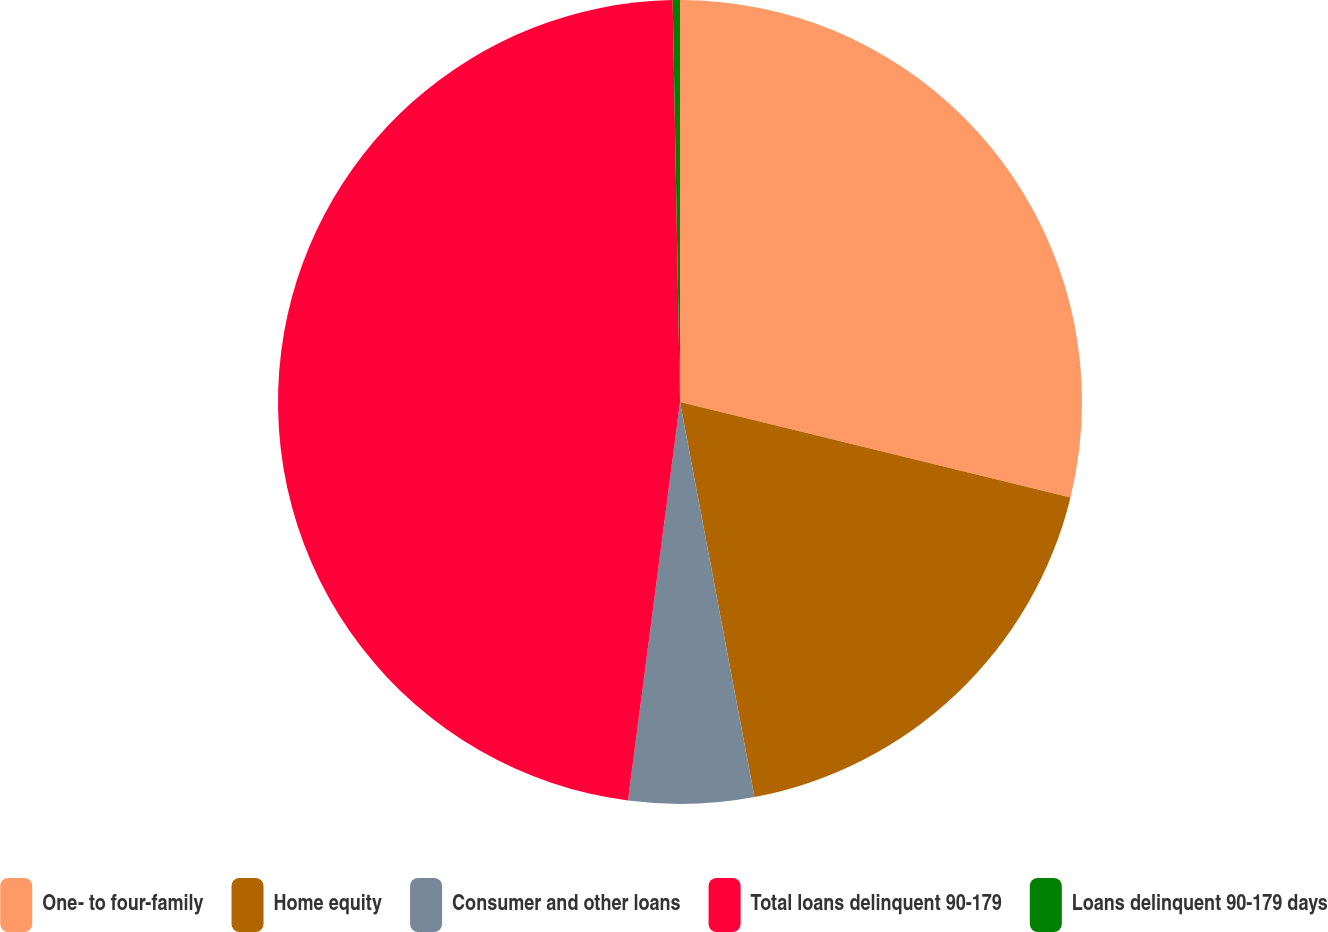<chart> <loc_0><loc_0><loc_500><loc_500><pie_chart><fcel>One- to four-family<fcel>Home equity<fcel>Consumer and other loans<fcel>Total loans delinquent 90-179<fcel>Loans delinquent 90-179 days<nl><fcel>28.81%<fcel>18.22%<fcel>5.03%<fcel>47.64%<fcel>0.29%<nl></chart> 